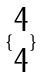<formula> <loc_0><loc_0><loc_500><loc_500>\{ \begin{matrix} 4 \\ 4 \end{matrix} \}</formula> 